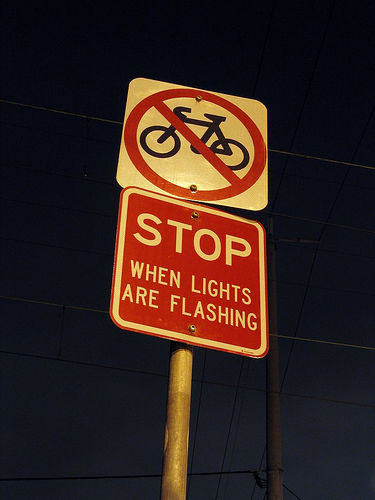Identify and read out the text in this image. STOP WHEN LIGHTS ARE FLASHING 